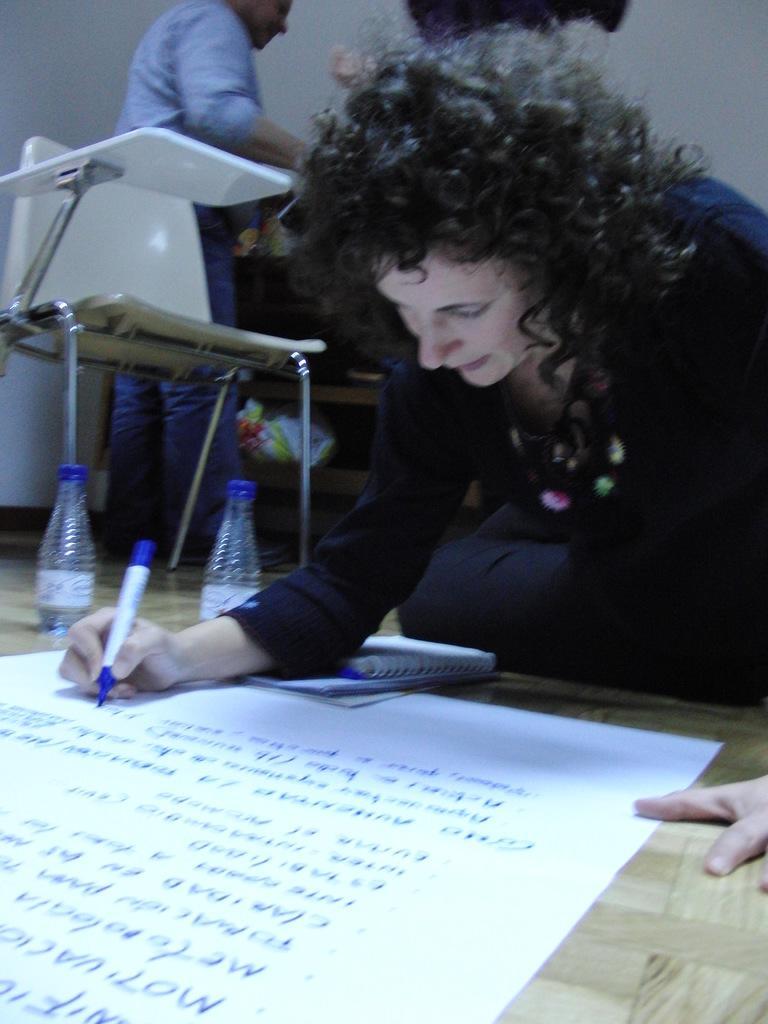In one or two sentences, can you explain what this image depicts? As we can see in the image there are two people, chair, bottles and a white color wall. The woman over here is writing on white color sheet. 